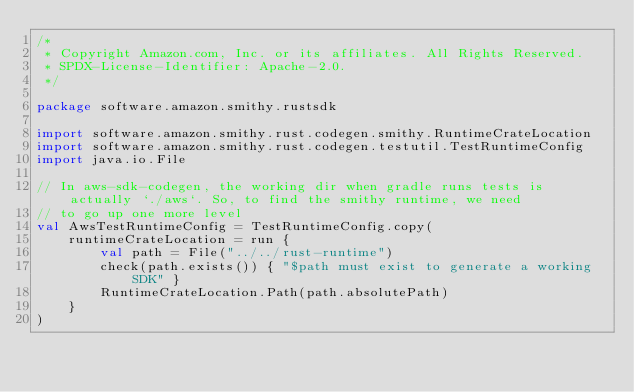Convert code to text. <code><loc_0><loc_0><loc_500><loc_500><_Kotlin_>/*
 * Copyright Amazon.com, Inc. or its affiliates. All Rights Reserved.
 * SPDX-License-Identifier: Apache-2.0.
 */

package software.amazon.smithy.rustsdk

import software.amazon.smithy.rust.codegen.smithy.RuntimeCrateLocation
import software.amazon.smithy.rust.codegen.testutil.TestRuntimeConfig
import java.io.File

// In aws-sdk-codegen, the working dir when gradle runs tests is actually `./aws`. So, to find the smithy runtime, we need
// to go up one more level
val AwsTestRuntimeConfig = TestRuntimeConfig.copy(
    runtimeCrateLocation = run {
        val path = File("../../rust-runtime")
        check(path.exists()) { "$path must exist to generate a working SDK" }
        RuntimeCrateLocation.Path(path.absolutePath)
    }
)
</code> 